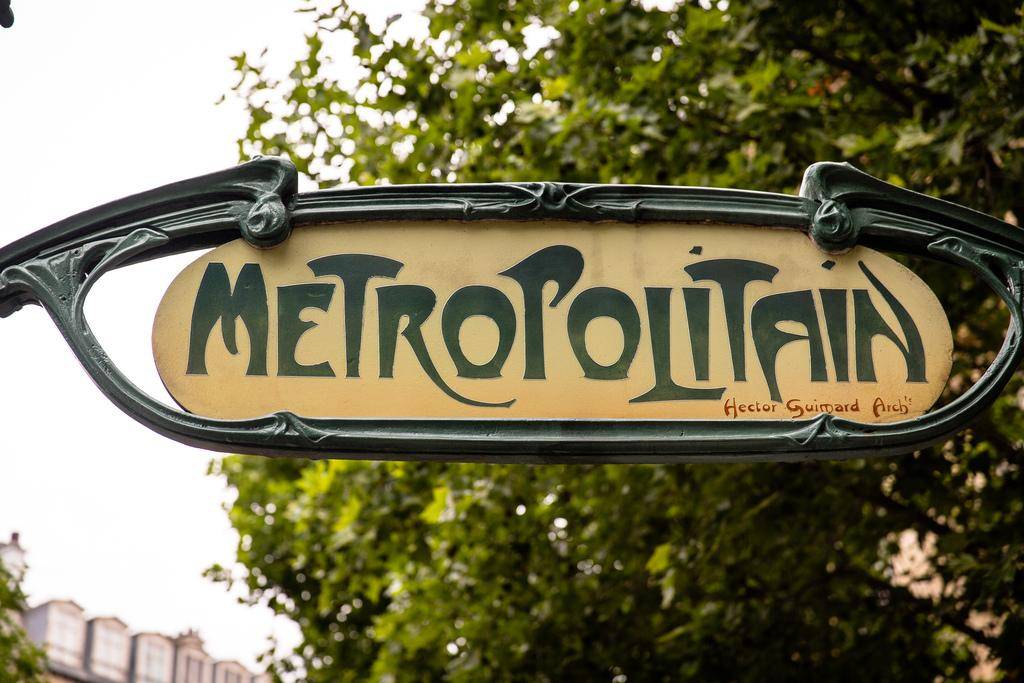What is the main object in the image? There is a name board in the image. What type of natural vegetation is present in the image? There are trees in the image. What part of the natural environment is visible in the image? The sky is visible in the image. What type of man-made structure is present in the image? There is a building in the image. Can you see any mist in the image? There is no mention of mist in the image, so it cannot be determined if any is present. Is the image set in outer space? The image is not set in outer space; it features a name board, trees, the sky, and a building. 